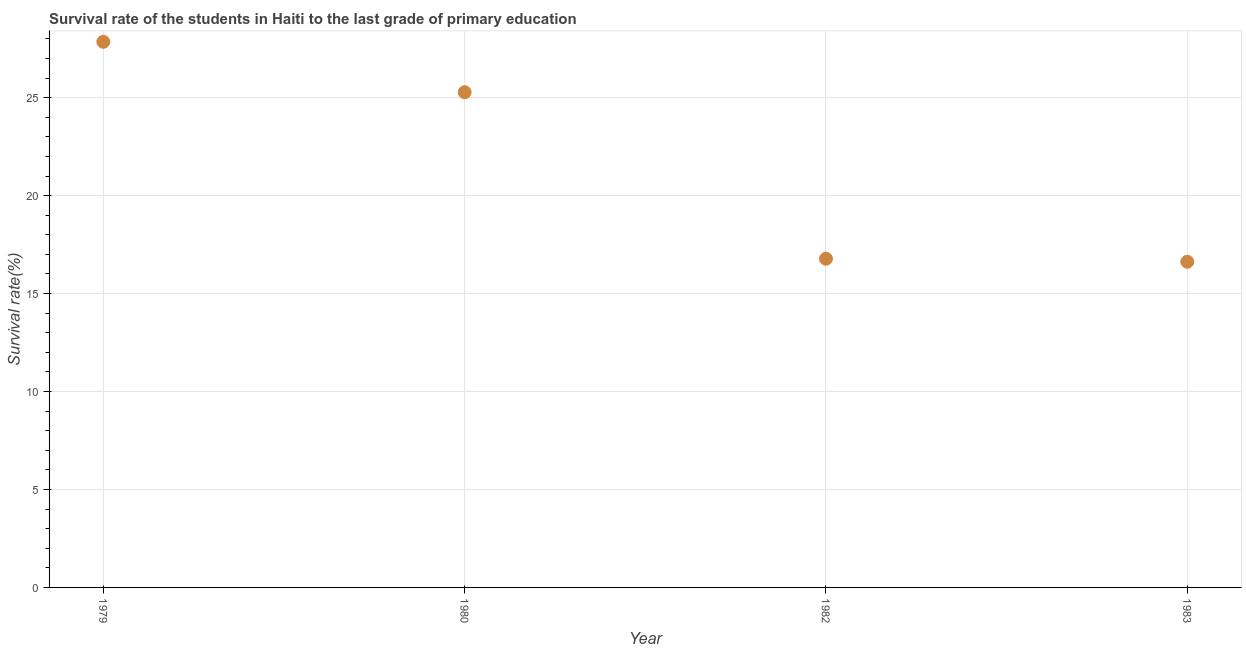What is the survival rate in primary education in 1983?
Keep it short and to the point. 16.62. Across all years, what is the maximum survival rate in primary education?
Provide a succinct answer. 27.85. Across all years, what is the minimum survival rate in primary education?
Offer a very short reply. 16.62. In which year was the survival rate in primary education maximum?
Your answer should be compact. 1979. What is the sum of the survival rate in primary education?
Make the answer very short. 86.53. What is the difference between the survival rate in primary education in 1980 and 1982?
Provide a short and direct response. 8.5. What is the average survival rate in primary education per year?
Provide a succinct answer. 21.63. What is the median survival rate in primary education?
Provide a short and direct response. 21.03. What is the ratio of the survival rate in primary education in 1980 to that in 1983?
Keep it short and to the point. 1.52. Is the survival rate in primary education in 1980 less than that in 1982?
Your response must be concise. No. Is the difference between the survival rate in primary education in 1979 and 1983 greater than the difference between any two years?
Offer a very short reply. Yes. What is the difference between the highest and the second highest survival rate in primary education?
Provide a succinct answer. 2.57. Is the sum of the survival rate in primary education in 1979 and 1980 greater than the maximum survival rate in primary education across all years?
Make the answer very short. Yes. What is the difference between the highest and the lowest survival rate in primary education?
Your response must be concise. 11.23. Does the survival rate in primary education monotonically increase over the years?
Give a very brief answer. No. How many dotlines are there?
Provide a succinct answer. 1. How many years are there in the graph?
Ensure brevity in your answer.  4. What is the difference between two consecutive major ticks on the Y-axis?
Provide a succinct answer. 5. What is the title of the graph?
Offer a terse response. Survival rate of the students in Haiti to the last grade of primary education. What is the label or title of the Y-axis?
Keep it short and to the point. Survival rate(%). What is the Survival rate(%) in 1979?
Offer a very short reply. 27.85. What is the Survival rate(%) in 1980?
Provide a short and direct response. 25.28. What is the Survival rate(%) in 1982?
Make the answer very short. 16.78. What is the Survival rate(%) in 1983?
Offer a very short reply. 16.62. What is the difference between the Survival rate(%) in 1979 and 1980?
Provide a short and direct response. 2.57. What is the difference between the Survival rate(%) in 1979 and 1982?
Give a very brief answer. 11.07. What is the difference between the Survival rate(%) in 1979 and 1983?
Ensure brevity in your answer.  11.23. What is the difference between the Survival rate(%) in 1980 and 1982?
Give a very brief answer. 8.5. What is the difference between the Survival rate(%) in 1980 and 1983?
Give a very brief answer. 8.65. What is the difference between the Survival rate(%) in 1982 and 1983?
Give a very brief answer. 0.15. What is the ratio of the Survival rate(%) in 1979 to that in 1980?
Ensure brevity in your answer.  1.1. What is the ratio of the Survival rate(%) in 1979 to that in 1982?
Keep it short and to the point. 1.66. What is the ratio of the Survival rate(%) in 1979 to that in 1983?
Keep it short and to the point. 1.68. What is the ratio of the Survival rate(%) in 1980 to that in 1982?
Offer a very short reply. 1.51. What is the ratio of the Survival rate(%) in 1980 to that in 1983?
Ensure brevity in your answer.  1.52. 